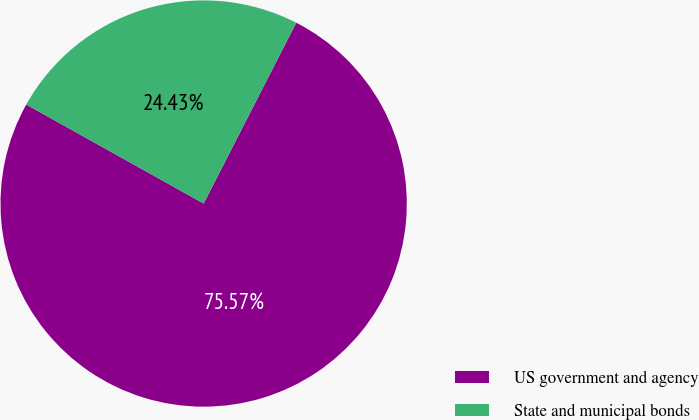<chart> <loc_0><loc_0><loc_500><loc_500><pie_chart><fcel>US government and agency<fcel>State and municipal bonds<nl><fcel>75.57%<fcel>24.43%<nl></chart> 